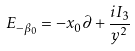Convert formula to latex. <formula><loc_0><loc_0><loc_500><loc_500>E _ { - \beta _ { 0 } } = - x _ { 0 } \partial + \frac { i I _ { 3 } } { y ^ { 2 } }</formula> 